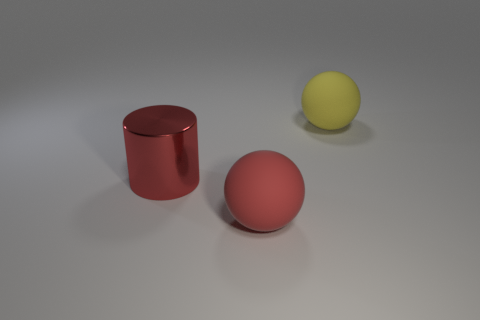Add 3 big metal cylinders. How many objects exist? 6 Subtract all yellow spheres. How many spheres are left? 1 Subtract all cylinders. How many objects are left? 2 Add 3 big red shiny things. How many big red shiny things are left? 4 Add 2 cyan metallic balls. How many cyan metallic balls exist? 2 Subtract 0 blue cubes. How many objects are left? 3 Subtract 2 spheres. How many spheres are left? 0 Subtract all cyan cylinders. Subtract all brown balls. How many cylinders are left? 1 Subtract all purple cylinders. How many cyan balls are left? 0 Subtract all large red metal things. Subtract all tiny blue things. How many objects are left? 2 